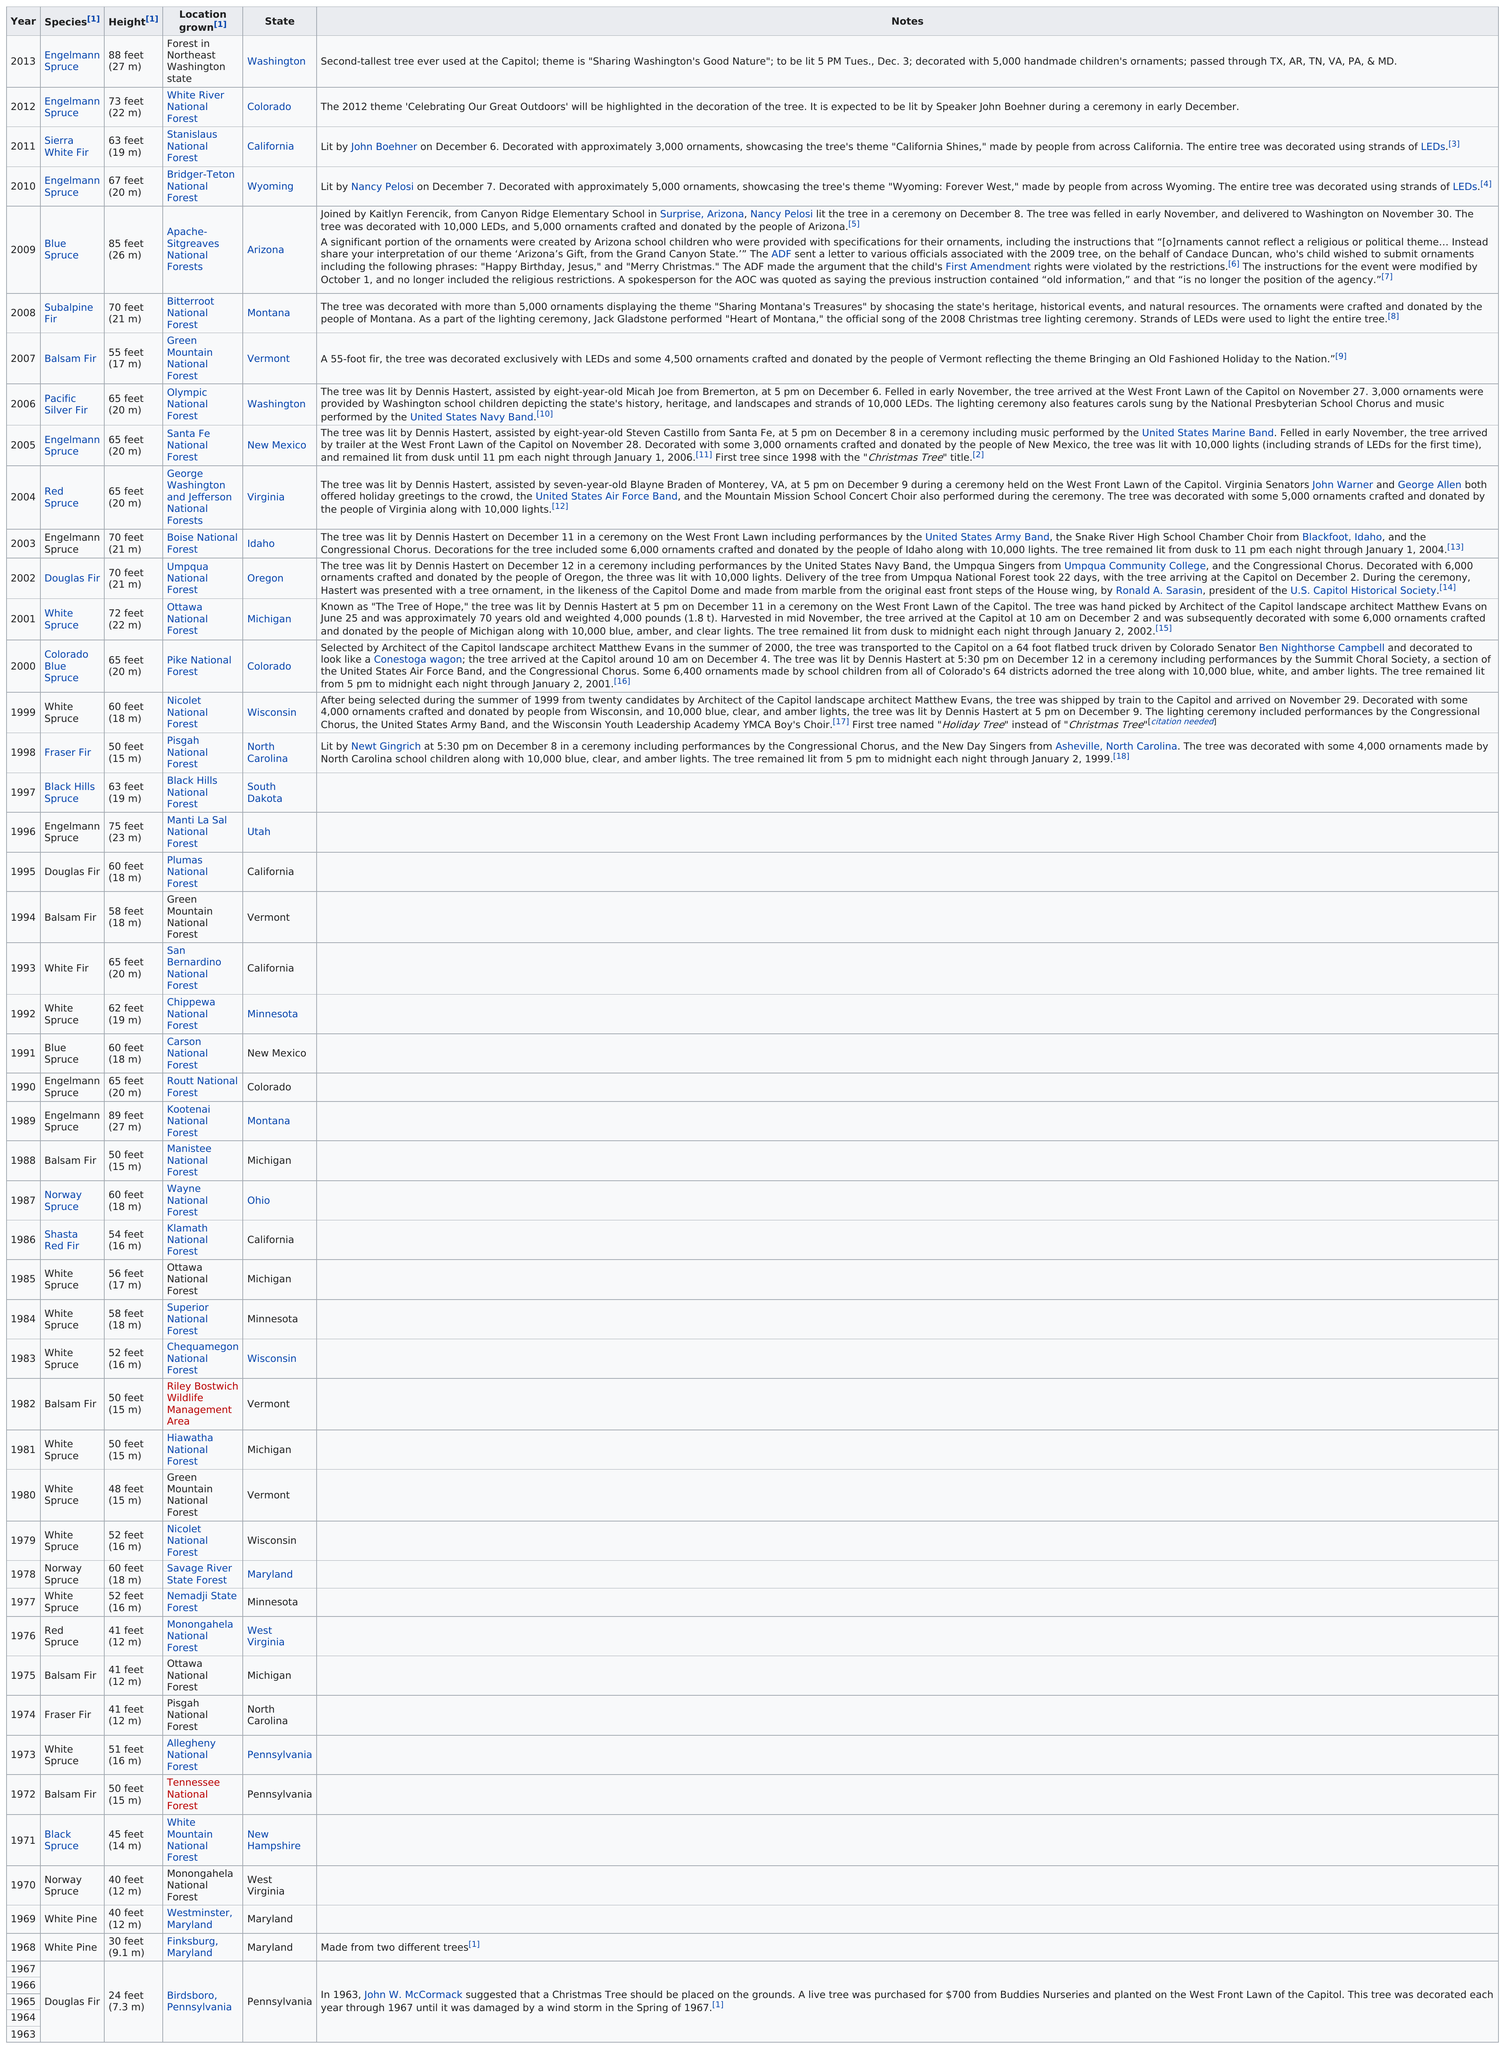Identify some key points in this picture. Douglas Fir is the species with the least height among all known species. The Engelmann Spruce was the tallest species of tree used in the construction of the treehouse. The total height of trees from California is 63 feet. The white spruce used in 1985 was sourced from Michigan. It is estimated that there are a significant number of trees that are at least 70 feet tall. 